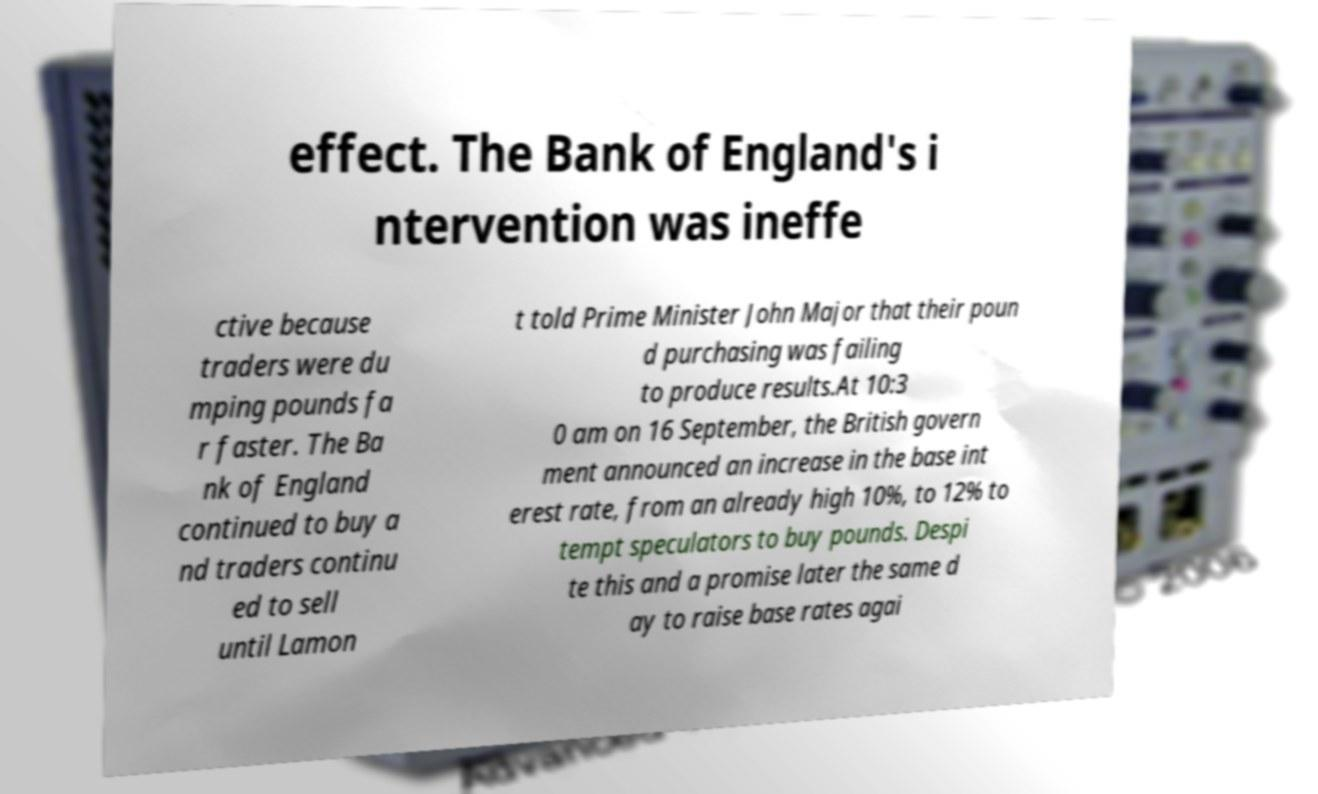For documentation purposes, I need the text within this image transcribed. Could you provide that? effect. The Bank of England's i ntervention was ineffe ctive because traders were du mping pounds fa r faster. The Ba nk of England continued to buy a nd traders continu ed to sell until Lamon t told Prime Minister John Major that their poun d purchasing was failing to produce results.At 10:3 0 am on 16 September, the British govern ment announced an increase in the base int erest rate, from an already high 10%, to 12% to tempt speculators to buy pounds. Despi te this and a promise later the same d ay to raise base rates agai 